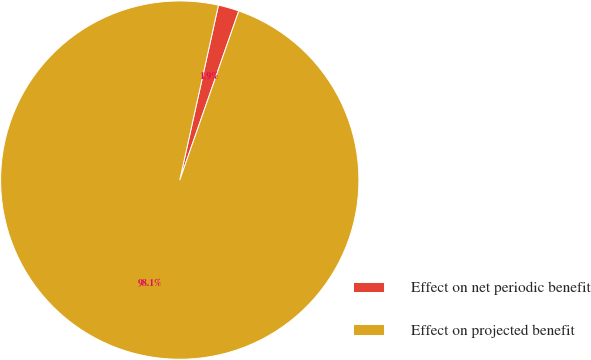Convert chart. <chart><loc_0><loc_0><loc_500><loc_500><pie_chart><fcel>Effect on net periodic benefit<fcel>Effect on projected benefit<nl><fcel>1.88%<fcel>98.12%<nl></chart> 